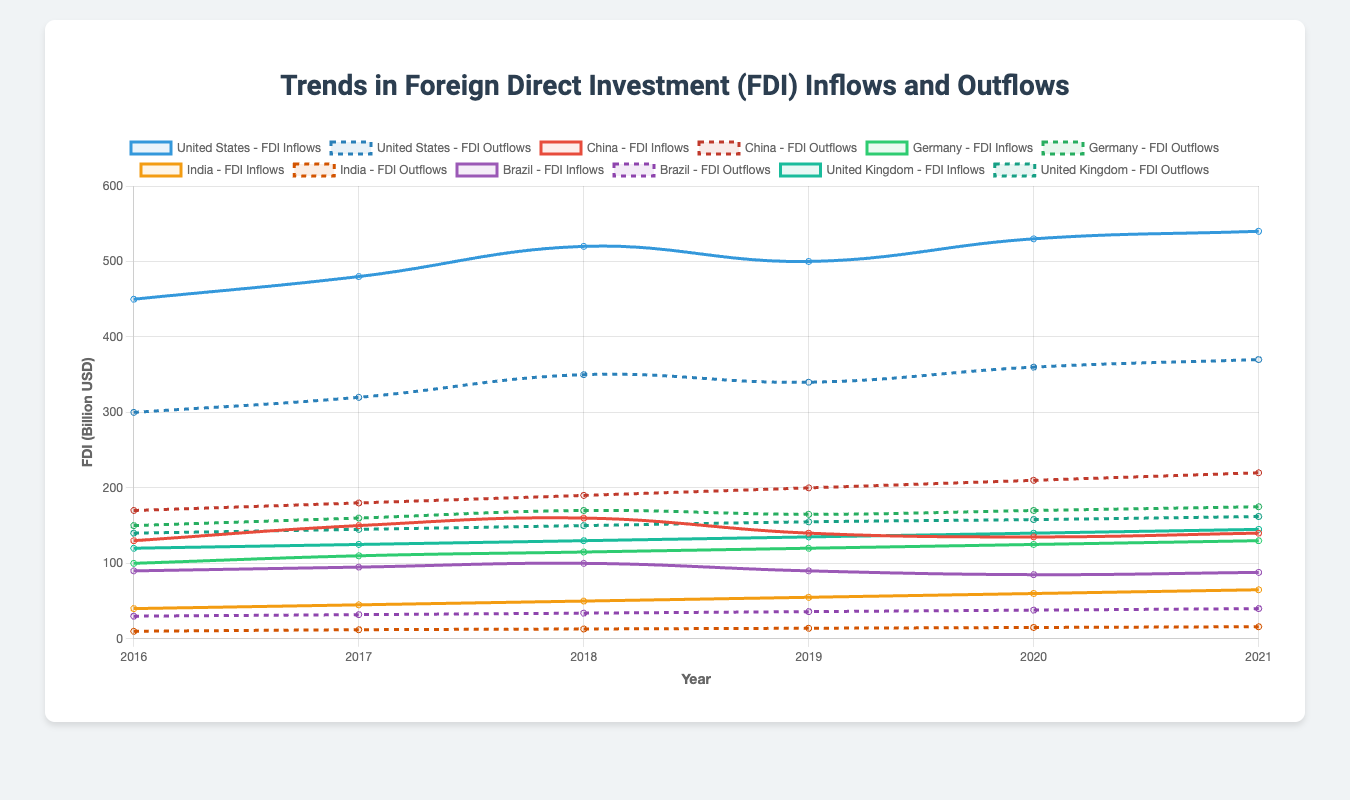Which country had the highest FDI inflow in 2021? By looking at the FDI Inflows lines for each country in 2021, we can see that the United States had the highest inflow with 540 billion USD.
Answer: United States Compare the FDI outflows of China and Germany in 2020. Which was higher? In 2020, China had an FDI outflow of 210 billion USD, while Germany had an FDI outflow of 170 billion USD. Clearly, China's outflow was higher.
Answer: China What was the total FDI inflow for India from 2016 to 2021? Adding up the FDI inflows for India from each year: 40 + 45 + 50 + 55 + 60 + 65 = 315 billion USD.
Answer: 315 billion USD Did any country have an equal amount of FDI inflow and outflow in any given year? By examining the visual representation for all countries, no country had equal FDI inflows and outflows in any given year.
Answer: No Between 2020 and 2021, which country had a greater increase in FDI inflows: Brazil or Germany? For Brazil: FDI inflows increased from 85 to 88 (an increase of 3 billion USD). For Germany: FDI inflows increased from 125 to 130 (an increase of 5 billion USD). Germany had the greater increase.
Answer: Germany Compare the trends of FDI inflows and outflows for the United Kingdom from 2016 to 2021. Over the years, both FDI inflows and outflows for the United Kingdom show a consistent upward trend. Inflows rose from 120 to 145 billion USD, while outflows increased from 140 to 162 billion USD.
Answer: Upward trend for both Which country had the smallest FDI outflow in 2021 and what was the amount? In 2021, India had the smallest FDI outflow with 16 billion USD, as seen in the chart data.
Answer: India, 16 billion USD Rate the growth in FDI inflows for the United States and China from 2016 to 2021. Which grew more? The United States grew from 450 to 540 (an increase of 90 billion USD). China fluctuated but remained close to 130-140 billion USD. The United States saw more significant growth.
Answer: United States Calculate the average FDI outflow for Brazil over the given years. Summing the FDI outflows for Brazil from 2016 to 2021: 30 + 32 + 34 + 36 + 38 + 40 = 210 billion USD. Dividing by the number of years (6): 210 / 6 = 35 billion USD.
Answer: 35 billion USD How did the FDI inflows for China trend from 2016 to 2021? The FDI inflows for China initially rose from 130 in 2016 to 160 in 2018, then declined to 140 by 2021. There is a general trend of slight fluctuation.
Answer: Fluctuated 